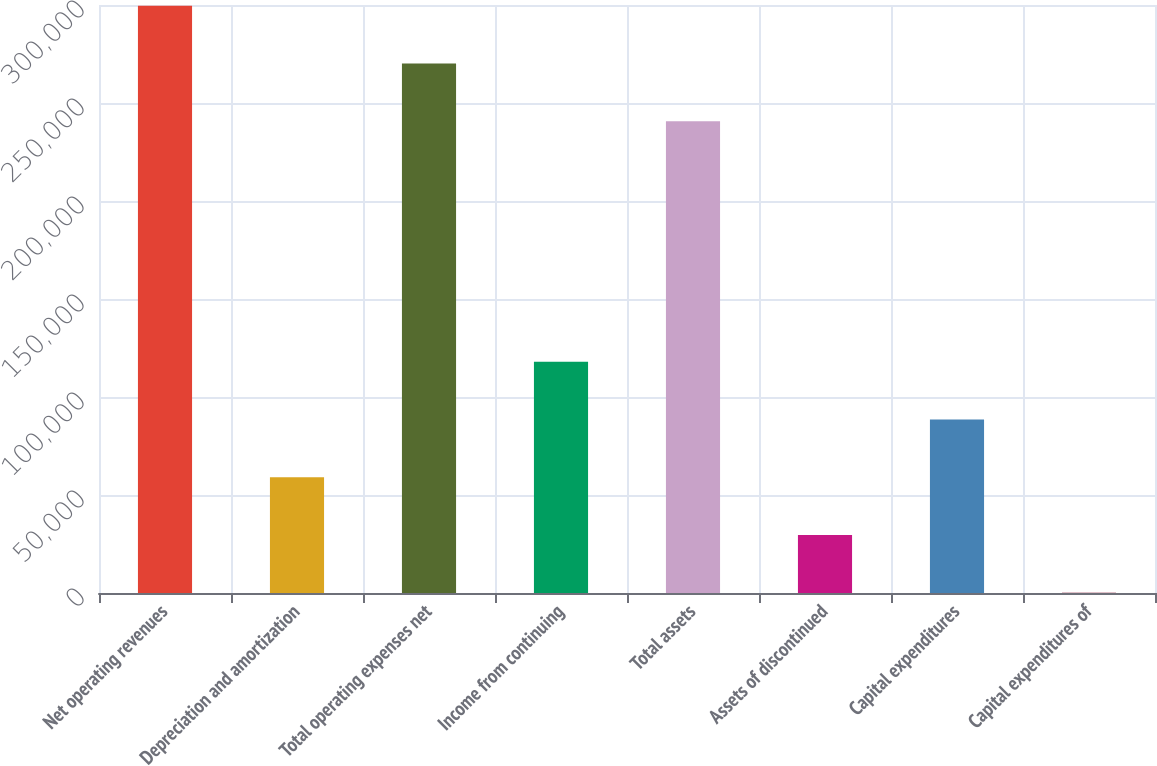Convert chart to OTSL. <chart><loc_0><loc_0><loc_500><loc_500><bar_chart><fcel>Net operating revenues<fcel>Depreciation and amortization<fcel>Total operating expenses net<fcel>Income from continuing<fcel>Total assets<fcel>Assets of discontinued<fcel>Capital expenditures<fcel>Capital expenditures of<nl><fcel>299634<fcel>59059<fcel>270176<fcel>117975<fcel>240718<fcel>29601<fcel>88517<fcel>143<nl></chart> 